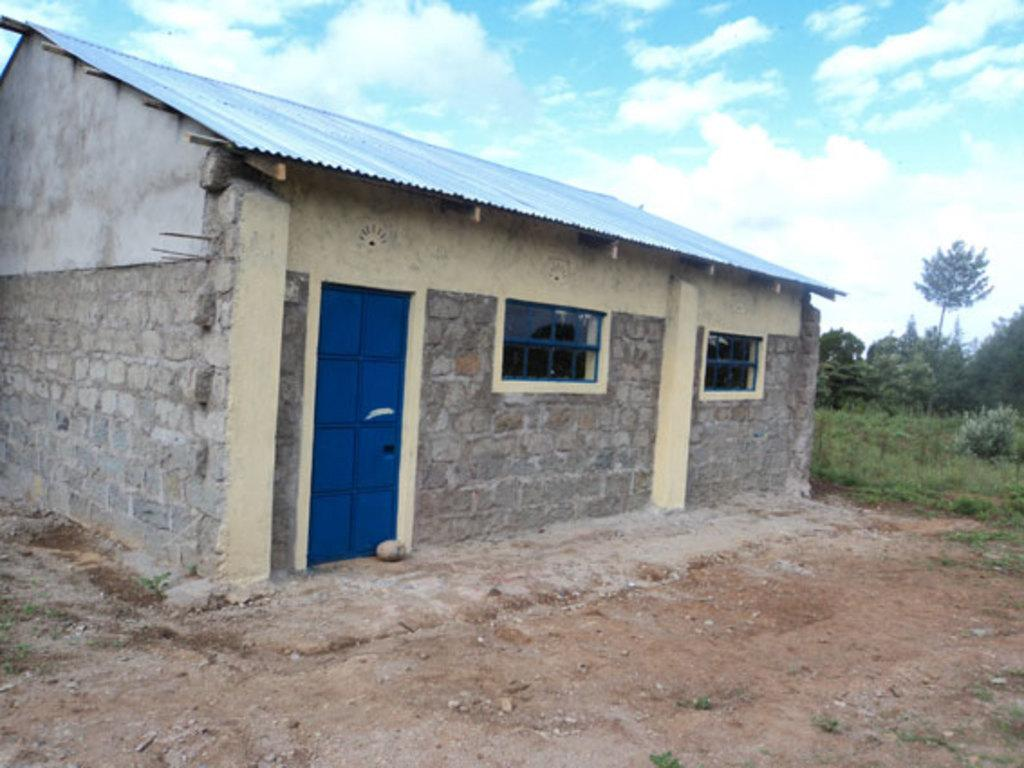What materials were used to construct the house in the image? The house is made up of cement sheets and bricks. How many entrances are there to the house? There is one door to the house. How many openings for light and ventilation are there in the house? There are two windows in the house. What type of vegetation is visible behind the house? There is grass and trees behind the house. What type of lawyer is standing next to the house in the image? There is no lawyer present in the image. --- Facts: 1. There is a person in the image. 2. The person is wearing a hat. 3. The person is holding a book. 4. The background is a park. 5. There are benches in the background. Absurd Topics: elephant, piano Conversation: Who or what is present in the image? There is a person in the image. What is the person wearing in the image? The person is wearing a hat. What is the person holding in the image? The person is holding a book. What can be seen in the background of the image? The background is a park. What type of seating is visible in the background? There are benches in the background. Reasoning: Let's think step by step in order to produce the conversation. We start by identifying the main subject in the image, which is the person. Then, we describe specific details about the person, such as the hat and the book they are holding. Next, we observe the actions of the person in the image, noting that they are holding a book. Finally, we describe the setting visible in the background of the image, which is a park with benches. Absurd Question/Answer: What type of elephant can be seen playing the piano in the image? There is no elephant or piano present in the image. 